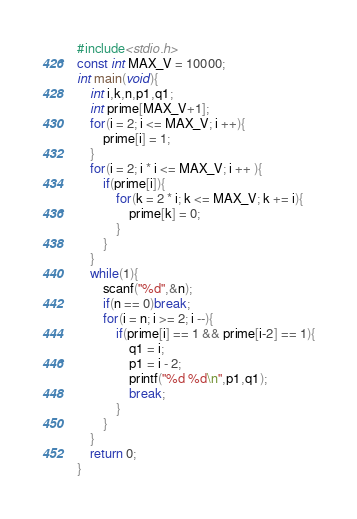<code> <loc_0><loc_0><loc_500><loc_500><_C_>#include<stdio.h>
const int MAX_V = 10000;
int main(void){
    int i,k,n,p1,q1;
    int prime[MAX_V+1];
    for(i = 2; i <= MAX_V; i ++){
        prime[i] = 1;
    }
    for(i = 2; i * i <= MAX_V; i ++ ){
        if(prime[i]){
            for(k = 2 * i; k <= MAX_V; k += i){
                prime[k] = 0;
            }
        }
    }
    while(1){
        scanf("%d",&n);
        if(n == 0)break;
        for(i = n; i >= 2; i --){
            if(prime[i] == 1 && prime[i-2] == 1){
                q1 = i;
                p1 = i - 2;
                printf("%d %d\n",p1,q1);
                break;
            }
        }
    }
    return 0;
}</code> 